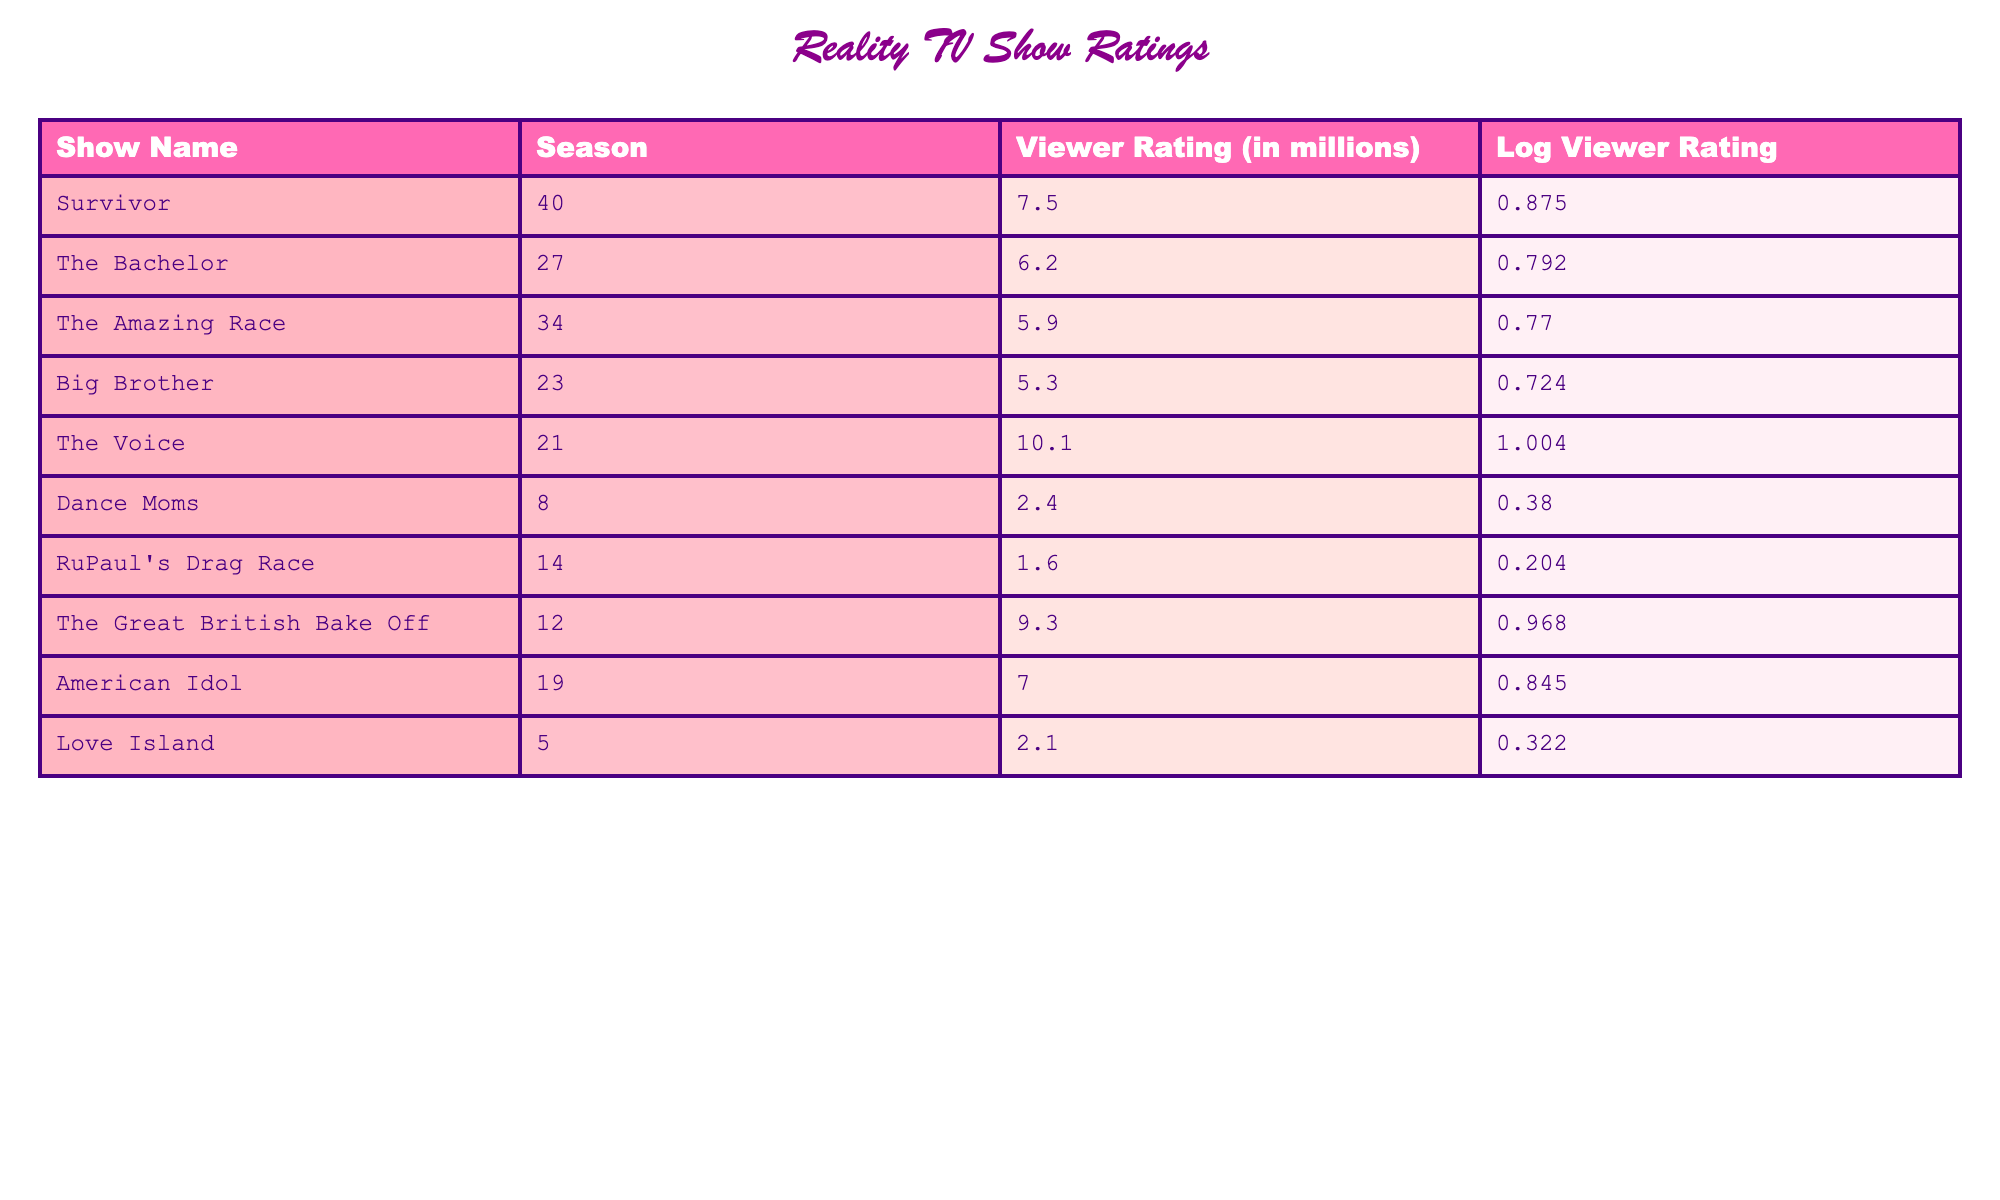What is the viewer rating of The Voice? The table lists The Voice with a viewer rating of 10.1 million.
Answer: 10.1 million Which show has the lowest viewer rating? Dance Moms has the lowest viewer rating at 2.4 million, as per the data in the table.
Answer: Dance Moms What is the average viewer rating of all the shows listed? To find the average, sum the viewer ratings: 7.5 + 6.2 + 5.9 + 5.3 + 10.1 + 2.4 + 1.6 + 9.3 + 7.0 + 2.1 = 58.4 million. There are 10 shows, so 58.4/10 = 5.84 million.
Answer: 5.84 million Is the viewer rating of RuPaul's Drag Race higher than that of Love Island? RuPaul's Drag Race has a viewer rating of 1.6 million and Love Island has 2.1 million. Since 1.6 is not greater than 2.1, the answer is no.
Answer: No What is the difference in viewer ratings between The Great British Bake Off and Big Brother? The Great British Bake Off has a viewer rating of 9.3 million, while Big Brother's rating is 5.3 million. The difference is 9.3 - 5.3 = 4 million.
Answer: 4 million How many shows have viewer ratings above 6 million? The shows with ratings above 6 million are Survivor (7.5), The Voice (10.1), The Great British Bake Off (9.3), and American Idol (7.0). That's a total of 4 shows.
Answer: 4 shows What is the sum of the logarithmic viewer ratings for all the shows? The sum of the logarithmic viewer ratings is: 0.875 + 0.792 + 0.770 + 0.724 + 1.004 + 0.380 + 0.204 + 0.968 + 0.845 + 0.322 = 7.088.
Answer: 7.088 Does The Bachelor have a higher logarithmic viewer rating than The Amazing Race? The Bachelor has a logarithmic rating of 0.792 and The Amazing Race has 0.770. Since 0.792 is greater than 0.770, the answer is yes.
Answer: Yes Which show has a logarithmic viewer rating closest to 0.800? The Bachelor has a logarithmic viewer rating of 0.792, which is closest to 0.800, as other shows do not have similar values.
Answer: The Bachelor 